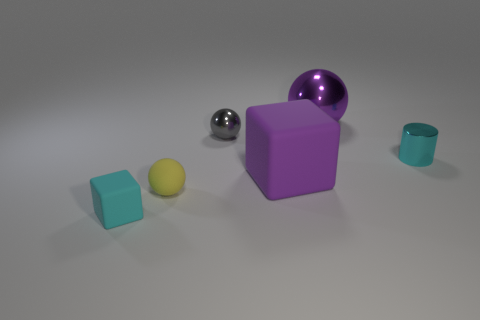How many cylinders are the same color as the tiny block?
Offer a terse response. 1. Is the shape of the yellow thing the same as the small gray metal thing?
Make the answer very short. Yes. Is there anything else that has the same shape as the cyan shiny object?
Your response must be concise. No. Is the material of the tiny cyan object that is to the left of the cyan metallic thing the same as the yellow ball?
Provide a succinct answer. Yes. The small object that is behind the large block and to the left of the purple sphere has what shape?
Ensure brevity in your answer.  Sphere. There is a cyan thing on the right side of the tiny rubber block; is there a shiny cylinder in front of it?
Provide a short and direct response. No. How many other objects are the same material as the large cube?
Your answer should be very brief. 2. Does the small metal thing that is behind the shiny cylinder have the same shape as the purple object that is behind the small gray sphere?
Your answer should be compact. Yes. Is the material of the small cube the same as the big purple cube?
Provide a succinct answer. Yes. What size is the cube behind the block that is on the left side of the tiny shiny object behind the cyan metal cylinder?
Your answer should be very brief. Large. 